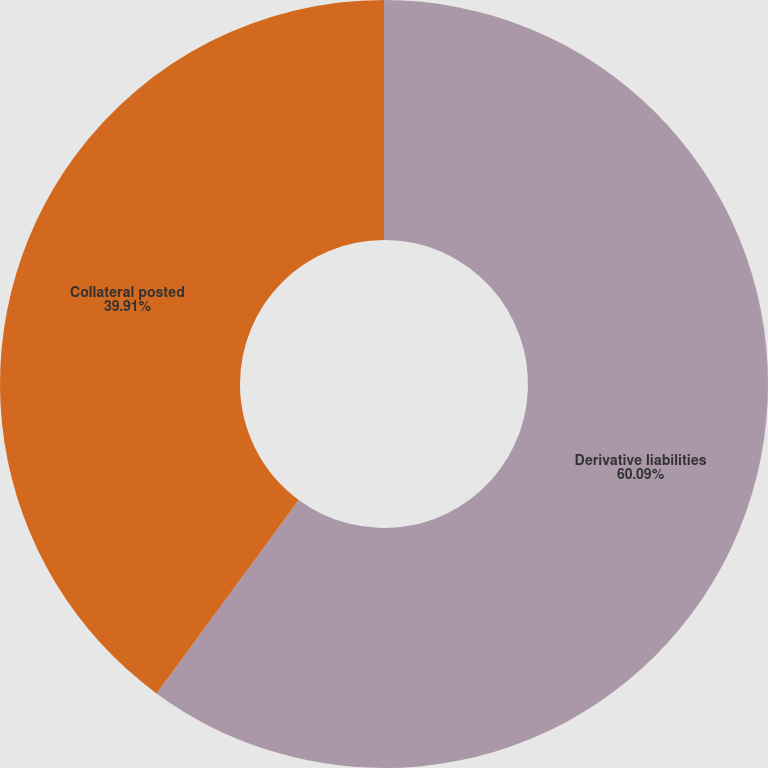Convert chart. <chart><loc_0><loc_0><loc_500><loc_500><pie_chart><fcel>Derivative liabilities<fcel>Collateral posted<nl><fcel>60.09%<fcel>39.91%<nl></chart> 